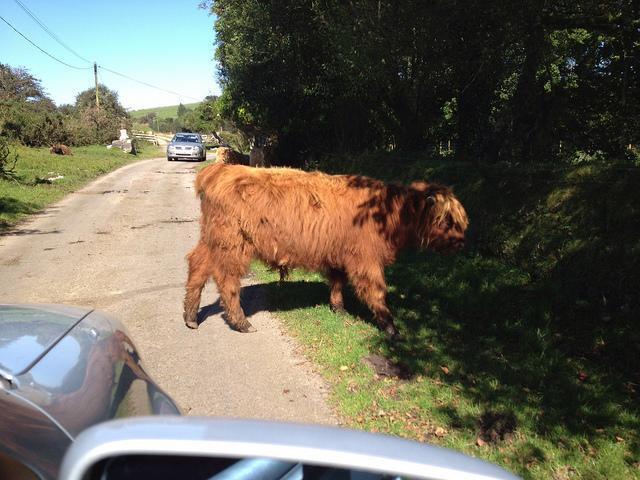What type of animal is shown?
Select the correct answer and articulate reasoning with the following format: 'Answer: answer
Rationale: rationale.'
Options: Domestic, aquatic, wild, stuffed. Answer: wild.
Rationale: Looks to be like some kind of longer hair cow. 